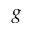<formula> <loc_0><loc_0><loc_500><loc_500>g</formula> 